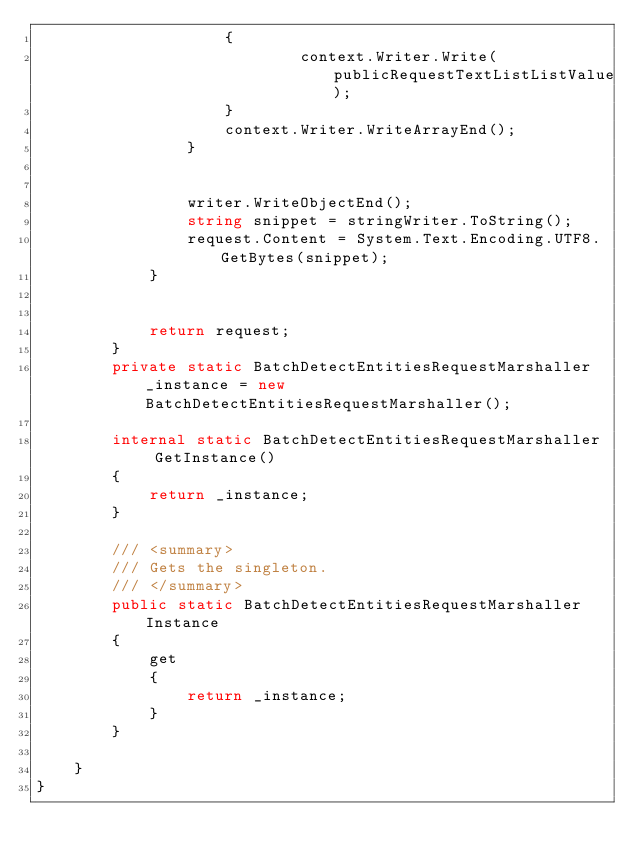<code> <loc_0><loc_0><loc_500><loc_500><_C#_>                    {
                            context.Writer.Write(publicRequestTextListListValue);
                    }
                    context.Writer.WriteArrayEnd();
                }

        
                writer.WriteObjectEnd();
                string snippet = stringWriter.ToString();
                request.Content = System.Text.Encoding.UTF8.GetBytes(snippet);
            }


            return request;
        }
        private static BatchDetectEntitiesRequestMarshaller _instance = new BatchDetectEntitiesRequestMarshaller();        

        internal static BatchDetectEntitiesRequestMarshaller GetInstance()
        {
            return _instance;
        }

        /// <summary>
        /// Gets the singleton.
        /// </summary>  
        public static BatchDetectEntitiesRequestMarshaller Instance
        {
            get
            {
                return _instance;
            }
        }

    }
}</code> 